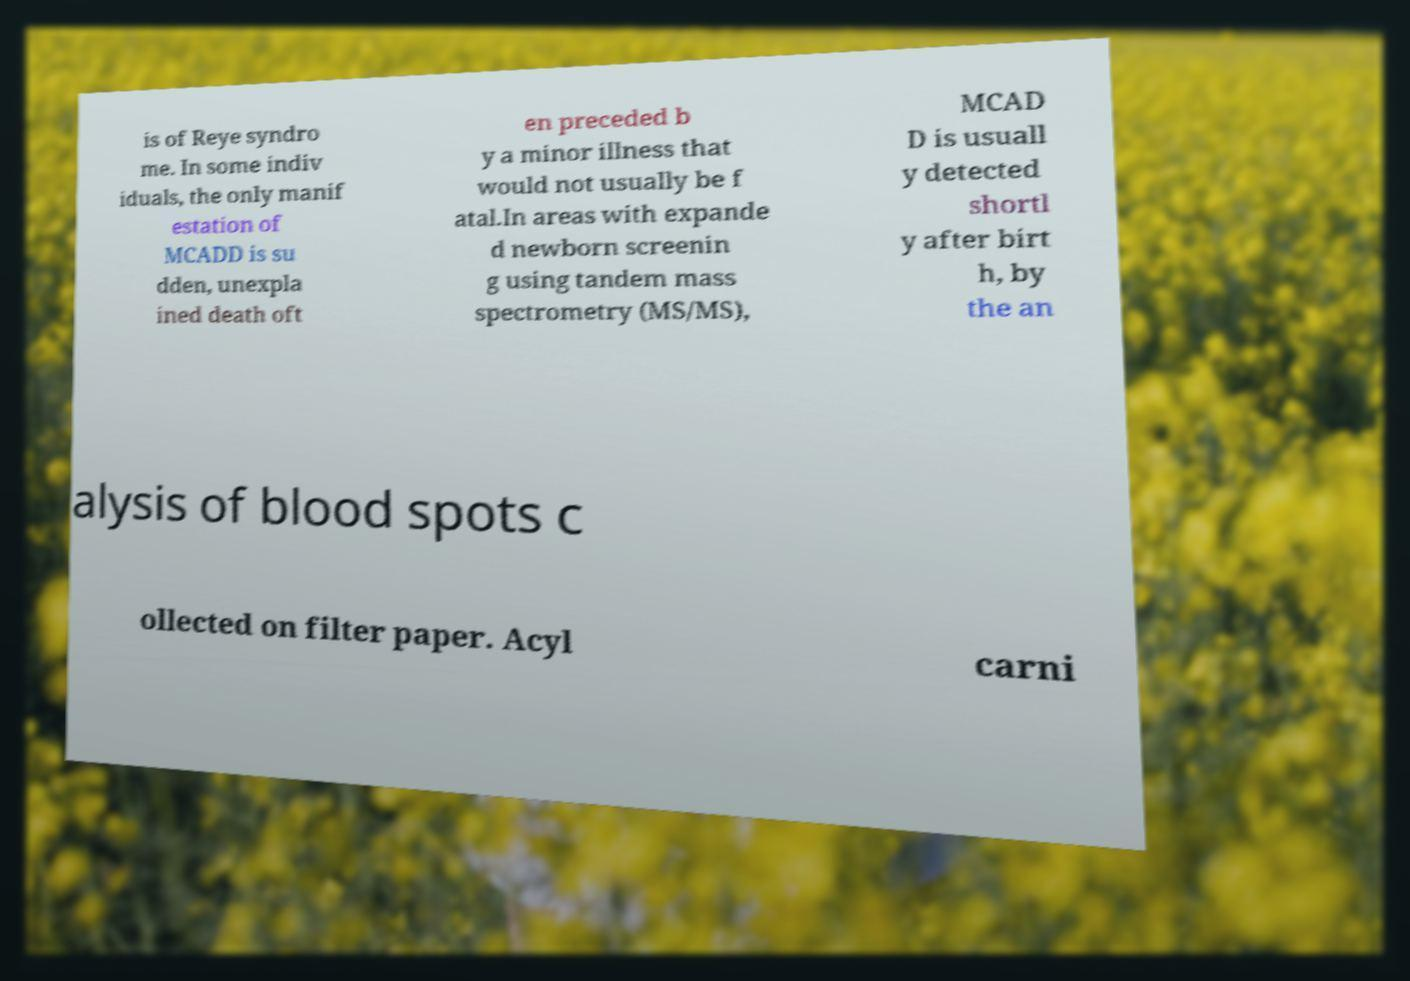Can you read and provide the text displayed in the image?This photo seems to have some interesting text. Can you extract and type it out for me? is of Reye syndro me. In some indiv iduals, the only manif estation of MCADD is su dden, unexpla ined death oft en preceded b y a minor illness that would not usually be f atal.In areas with expande d newborn screenin g using tandem mass spectrometry (MS/MS), MCAD D is usuall y detected shortl y after birt h, by the an alysis of blood spots c ollected on filter paper. Acyl carni 